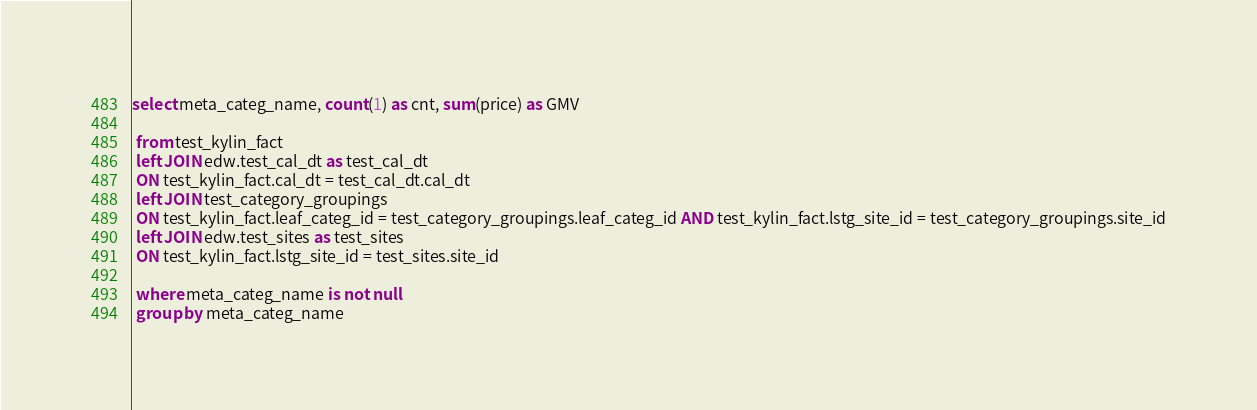<code> <loc_0><loc_0><loc_500><loc_500><_SQL_>
select meta_categ_name, count(1) as cnt, sum(price) as GMV 

 from test_kylin_fact 
 left JOIN edw.test_cal_dt as test_cal_dt
 ON test_kylin_fact.cal_dt = test_cal_dt.cal_dt
 left JOIN test_category_groupings
 ON test_kylin_fact.leaf_categ_id = test_category_groupings.leaf_categ_id AND test_kylin_fact.lstg_site_id = test_category_groupings.site_id
 left JOIN edw.test_sites as test_sites
 ON test_kylin_fact.lstg_site_id = test_sites.site_id

 where meta_categ_name is not null
 group by meta_categ_name 
</code> 